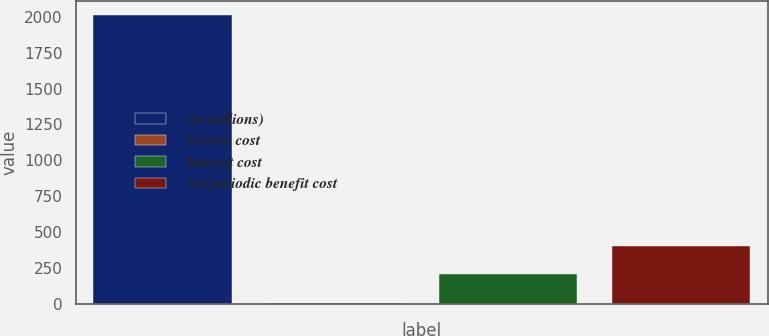<chart> <loc_0><loc_0><loc_500><loc_500><bar_chart><fcel>(in millions)<fcel>Service cost<fcel>Interest cost<fcel>Net periodic benefit cost<nl><fcel>2011<fcel>3<fcel>203.8<fcel>404.6<nl></chart> 